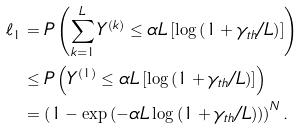<formula> <loc_0><loc_0><loc_500><loc_500>\ell _ { 1 } & = P \left ( \sum _ { k = 1 } ^ { L } { Y ^ { ( k ) } } \leq \alpha L \left [ \log \left ( 1 + \gamma _ { t h } / L \right ) \right ] \right ) \\ & \leq P \left ( Y ^ { ( 1 ) } \leq \alpha L \left [ \log \left ( 1 + \gamma _ { t h } / L \right ) \right ] \right ) \\ & = \left ( 1 - \exp \left ( - \alpha L \log \left ( 1 + \gamma _ { t h } / L \right ) \right ) \right ) ^ { N } .</formula> 